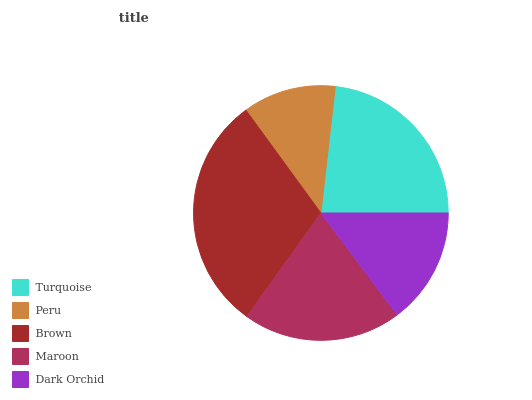Is Peru the minimum?
Answer yes or no. Yes. Is Brown the maximum?
Answer yes or no. Yes. Is Brown the minimum?
Answer yes or no. No. Is Peru the maximum?
Answer yes or no. No. Is Brown greater than Peru?
Answer yes or no. Yes. Is Peru less than Brown?
Answer yes or no. Yes. Is Peru greater than Brown?
Answer yes or no. No. Is Brown less than Peru?
Answer yes or no. No. Is Maroon the high median?
Answer yes or no. Yes. Is Maroon the low median?
Answer yes or no. Yes. Is Turquoise the high median?
Answer yes or no. No. Is Peru the low median?
Answer yes or no. No. 